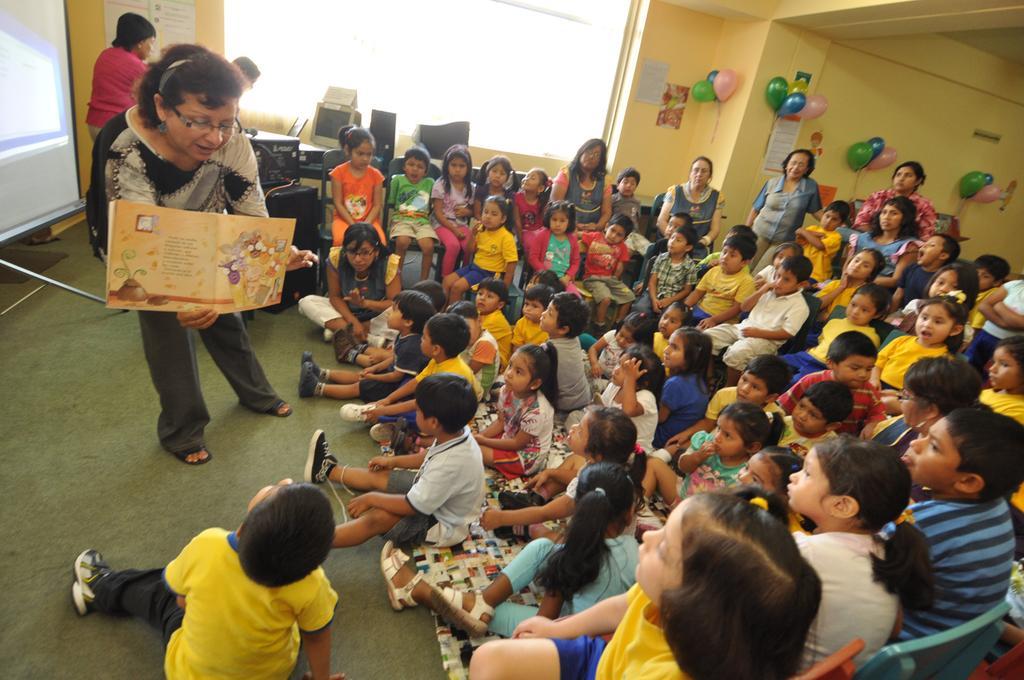Describe this image in one or two sentences. In this picture we can see the inside view of a building. Inside the building, some people are standing, some people are sitting on the floor and some kids are sitting on chairs. A woman is holding a book. Behind the woman there is a projector screen, monitors and some objects. Behind the people there is a window and there are balloons and posters on the wall. 